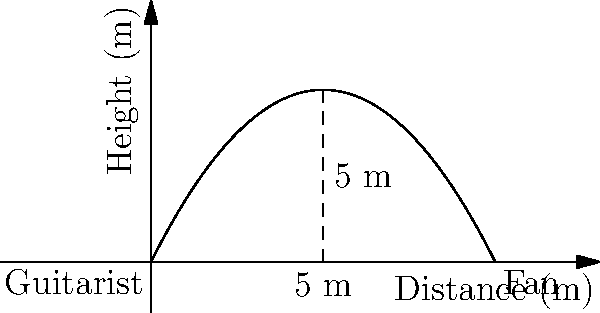Rock on, guitar hero! You're at the edge of the stage, about to launch your signature pick into the crowd. The trajectory of your epic throw follows the function $h(x) = -0.2x^2 + 2x$, where $h$ is the height in meters and $x$ is the horizontal distance in meters. If your most devoted fan is standing 10 meters away, at what distance from you will the pick reach its maximum height? Get ready to blow their minds! Let's shred through this problem step by step:

1) The trajectory of the pick is given by $h(x) = -0.2x^2 + 2x$.

2) To find the maximum height, we need to find where the derivative of $h(x)$ equals zero.

3) Let's differentiate $h(x)$:
   $h'(x) = -0.4x + 2$

4) Set $h'(x) = 0$ and solve for $x$:
   $-0.4x + 2 = 0$
   $-0.4x = -2$
   $x = 5$

5) To confirm this is a maximum (not a minimum), we can check the second derivative:
   $h''(x) = -0.4$, which is negative, confirming a maximum.

6) Therefore, the pick reaches its maximum height at $x = 5$ meters.

Rock on! The pick will reach its highest point halfway between you and your fan, creating a perfect arc for maximum dramatic effect!
Answer: 5 meters 